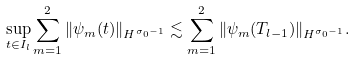<formula> <loc_0><loc_0><loc_500><loc_500>\sup _ { t \in I _ { l } } \sum _ { m = 1 } ^ { 2 } \| \psi _ { m } ( t ) \| _ { H ^ { \sigma _ { 0 } - 1 } } \lesssim \sum _ { m = 1 } ^ { 2 } \| \psi _ { m } ( T _ { l - 1 } ) \| _ { H ^ { \sigma _ { 0 } - 1 } } .</formula> 